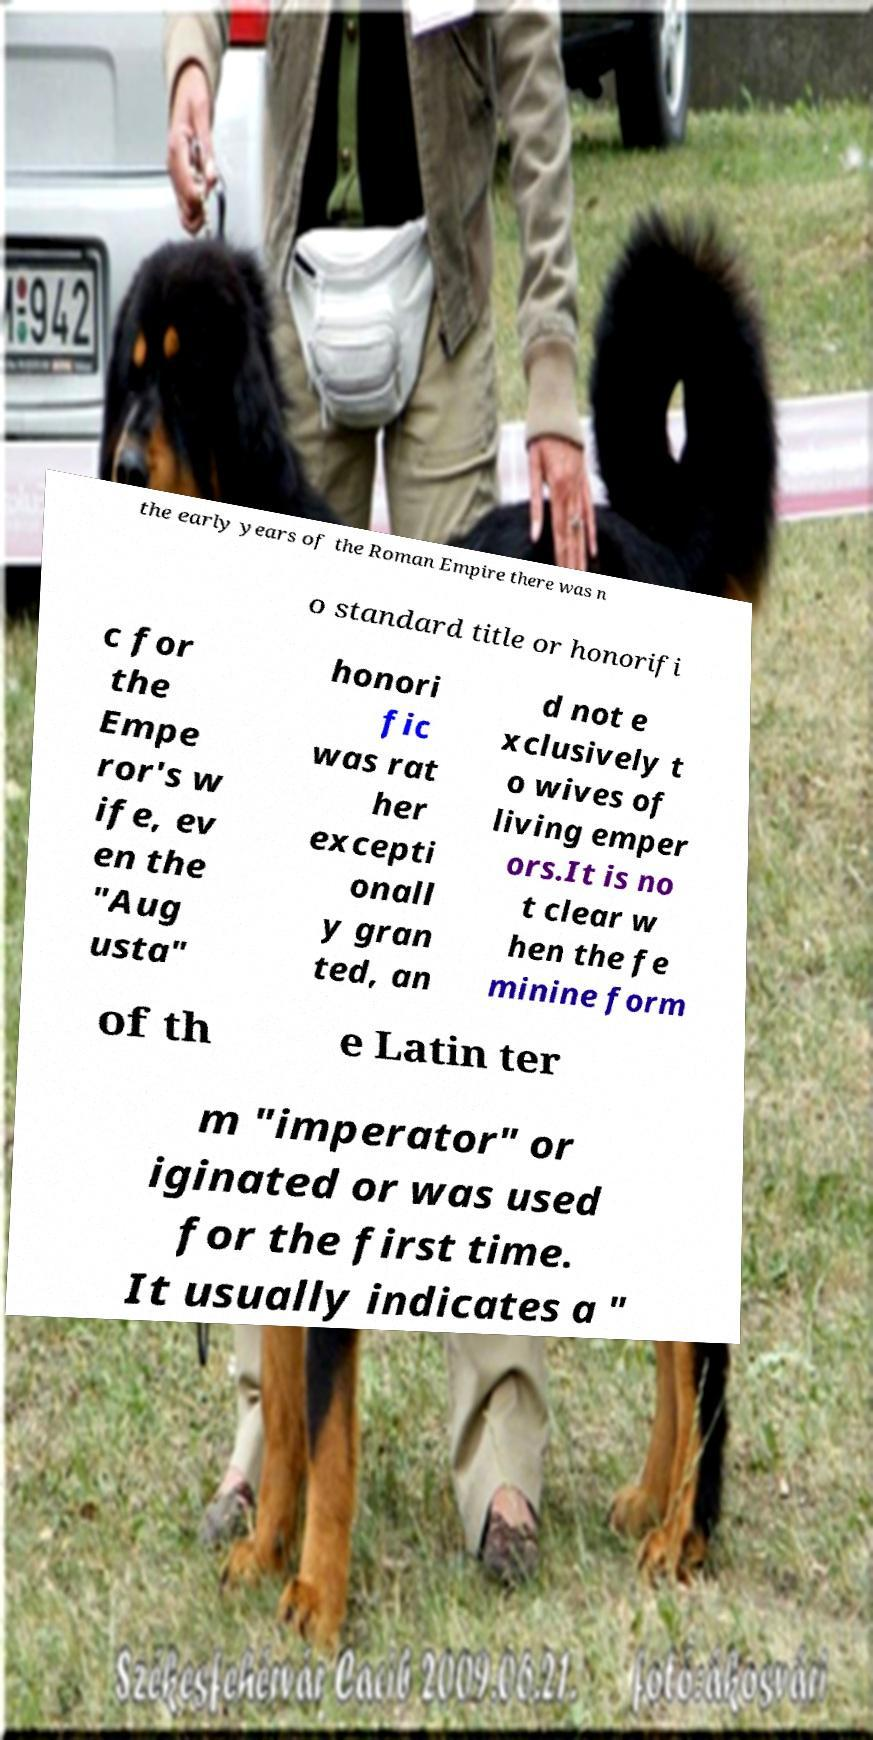There's text embedded in this image that I need extracted. Can you transcribe it verbatim? the early years of the Roman Empire there was n o standard title or honorifi c for the Empe ror's w ife, ev en the "Aug usta" honori fic was rat her excepti onall y gran ted, an d not e xclusively t o wives of living emper ors.It is no t clear w hen the fe minine form of th e Latin ter m "imperator" or iginated or was used for the first time. It usually indicates a " 